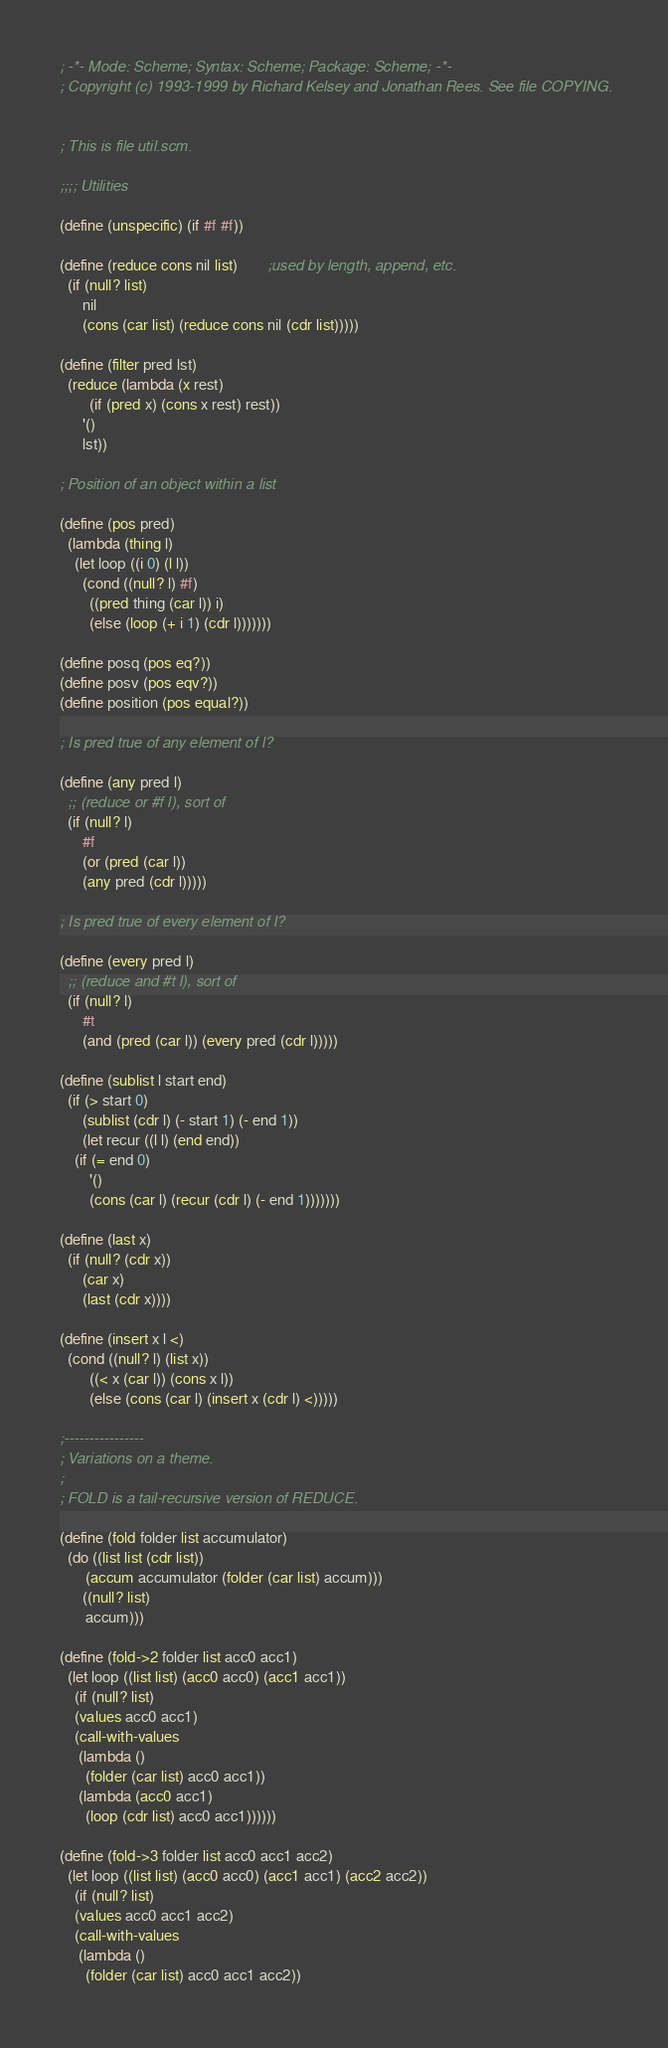Convert code to text. <code><loc_0><loc_0><loc_500><loc_500><_Scheme_>; -*- Mode: Scheme; Syntax: Scheme; Package: Scheme; -*-
; Copyright (c) 1993-1999 by Richard Kelsey and Jonathan Rees. See file COPYING.


; This is file util.scm.

;;;; Utilities

(define (unspecific) (if #f #f))

(define (reduce cons nil list)		;used by length, append, etc.
  (if (null? list)
      nil
      (cons (car list) (reduce cons nil (cdr list)))))

(define (filter pred lst)
  (reduce (lambda (x rest)
	    (if (pred x) (cons x rest) rest))
	  '()
	  lst))

; Position of an object within a list

(define (pos pred)
  (lambda (thing l)
    (let loop ((i 0) (l l))
      (cond ((null? l) #f)
	    ((pred thing (car l)) i)
	    (else (loop (+ i 1) (cdr l)))))))

(define posq (pos eq?))
(define posv (pos eqv?))
(define position (pos equal?))

; Is pred true of any element of l?

(define (any pred l)
  ;; (reduce or #f l), sort of
  (if (null? l)
      #f
      (or (pred (car l))
	  (any pred (cdr l)))))

; Is pred true of every element of l?

(define (every pred l)
  ;; (reduce and #t l), sort of
  (if (null? l)
      #t
      (and (pred (car l)) (every pred (cdr l)))))

(define (sublist l start end)
  (if (> start 0)
      (sublist (cdr l) (- start 1) (- end 1))
      (let recur ((l l) (end end))
	(if (= end 0)
	    '()
	    (cons (car l) (recur (cdr l) (- end 1)))))))

(define (last x)
  (if (null? (cdr x))
      (car x)
      (last (cdr x))))

(define (insert x l <)
  (cond ((null? l) (list x))
        ((< x (car l)) (cons x l))
        (else (cons (car l) (insert x (cdr l) <)))))

;----------------
; Variations on a theme.
;
; FOLD is a tail-recursive version of REDUCE.

(define (fold folder list accumulator)
  (do ((list list (cdr list))
       (accum accumulator (folder (car list) accum)))
      ((null? list)
       accum)))

(define (fold->2 folder list acc0 acc1)
  (let loop ((list list) (acc0 acc0) (acc1 acc1))
    (if (null? list)
	(values acc0 acc1)
	(call-with-values
	 (lambda ()
	   (folder (car list) acc0 acc1))
	 (lambda (acc0 acc1)
	   (loop (cdr list) acc0 acc1))))))

(define (fold->3 folder list acc0 acc1 acc2)
  (let loop ((list list) (acc0 acc0) (acc1 acc1) (acc2 acc2))
    (if (null? list)
	(values acc0 acc1 acc2)
	(call-with-values
	 (lambda ()
	   (folder (car list) acc0 acc1 acc2))</code> 